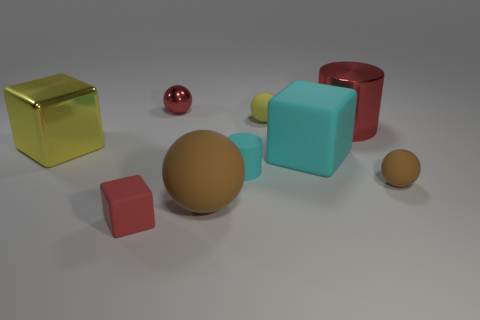Subtract all tiny red shiny balls. How many balls are left? 3 Subtract all balls. How many objects are left? 5 Add 1 red shiny spheres. How many objects exist? 10 Subtract all red cubes. How many cubes are left? 2 Subtract 2 cylinders. How many cylinders are left? 0 Subtract all large metallic cubes. Subtract all big blocks. How many objects are left? 6 Add 4 red cylinders. How many red cylinders are left? 5 Add 7 big matte spheres. How many big matte spheres exist? 8 Subtract 1 yellow balls. How many objects are left? 8 Subtract all green blocks. Subtract all yellow cylinders. How many blocks are left? 3 